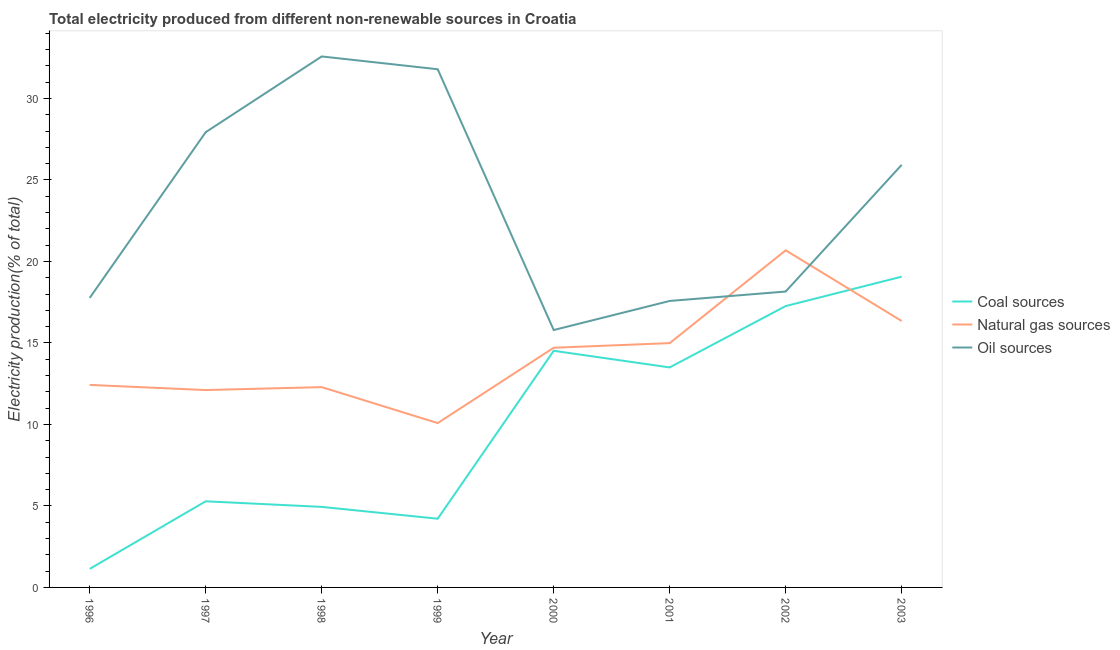Does the line corresponding to percentage of electricity produced by natural gas intersect with the line corresponding to percentage of electricity produced by coal?
Provide a short and direct response. Yes. Is the number of lines equal to the number of legend labels?
Offer a very short reply. Yes. What is the percentage of electricity produced by oil sources in 2002?
Your response must be concise. 18.15. Across all years, what is the maximum percentage of electricity produced by coal?
Provide a succinct answer. 19.06. Across all years, what is the minimum percentage of electricity produced by oil sources?
Provide a succinct answer. 15.79. In which year was the percentage of electricity produced by natural gas minimum?
Your response must be concise. 1999. What is the total percentage of electricity produced by natural gas in the graph?
Ensure brevity in your answer.  113.62. What is the difference between the percentage of electricity produced by oil sources in 1997 and that in 1998?
Your response must be concise. -4.65. What is the difference between the percentage of electricity produced by oil sources in 1997 and the percentage of electricity produced by natural gas in 1999?
Offer a very short reply. 17.85. What is the average percentage of electricity produced by coal per year?
Provide a succinct answer. 9.99. In the year 2002, what is the difference between the percentage of electricity produced by coal and percentage of electricity produced by oil sources?
Offer a terse response. -0.89. What is the ratio of the percentage of electricity produced by coal in 1999 to that in 2001?
Your response must be concise. 0.31. Is the percentage of electricity produced by coal in 1997 less than that in 2003?
Provide a short and direct response. Yes. What is the difference between the highest and the second highest percentage of electricity produced by natural gas?
Give a very brief answer. 4.34. What is the difference between the highest and the lowest percentage of electricity produced by natural gas?
Ensure brevity in your answer.  10.6. Is the sum of the percentage of electricity produced by natural gas in 2000 and 2003 greater than the maximum percentage of electricity produced by oil sources across all years?
Ensure brevity in your answer.  No. Is it the case that in every year, the sum of the percentage of electricity produced by coal and percentage of electricity produced by natural gas is greater than the percentage of electricity produced by oil sources?
Your answer should be compact. No. Is the percentage of electricity produced by natural gas strictly greater than the percentage of electricity produced by oil sources over the years?
Your answer should be very brief. No. Is the percentage of electricity produced by natural gas strictly less than the percentage of electricity produced by oil sources over the years?
Give a very brief answer. No. How many years are there in the graph?
Offer a very short reply. 8. Are the values on the major ticks of Y-axis written in scientific E-notation?
Provide a succinct answer. No. Does the graph contain any zero values?
Keep it short and to the point. No. How are the legend labels stacked?
Give a very brief answer. Vertical. What is the title of the graph?
Your answer should be very brief. Total electricity produced from different non-renewable sources in Croatia. What is the Electricity production(% of total) of Coal sources in 1996?
Your answer should be compact. 1.14. What is the Electricity production(% of total) of Natural gas sources in 1996?
Give a very brief answer. 12.42. What is the Electricity production(% of total) in Oil sources in 1996?
Your answer should be compact. 17.76. What is the Electricity production(% of total) in Coal sources in 1997?
Keep it short and to the point. 5.28. What is the Electricity production(% of total) of Natural gas sources in 1997?
Your answer should be very brief. 12.11. What is the Electricity production(% of total) in Oil sources in 1997?
Provide a short and direct response. 27.93. What is the Electricity production(% of total) in Coal sources in 1998?
Offer a terse response. 4.94. What is the Electricity production(% of total) in Natural gas sources in 1998?
Your response must be concise. 12.29. What is the Electricity production(% of total) in Oil sources in 1998?
Your answer should be very brief. 32.57. What is the Electricity production(% of total) of Coal sources in 1999?
Give a very brief answer. 4.22. What is the Electricity production(% of total) in Natural gas sources in 1999?
Provide a succinct answer. 10.08. What is the Electricity production(% of total) of Oil sources in 1999?
Your response must be concise. 31.79. What is the Electricity production(% of total) of Coal sources in 2000?
Your response must be concise. 14.52. What is the Electricity production(% of total) of Natural gas sources in 2000?
Provide a succinct answer. 14.7. What is the Electricity production(% of total) of Oil sources in 2000?
Give a very brief answer. 15.79. What is the Electricity production(% of total) of Coal sources in 2001?
Make the answer very short. 13.5. What is the Electricity production(% of total) in Natural gas sources in 2001?
Your answer should be very brief. 14.99. What is the Electricity production(% of total) of Oil sources in 2001?
Provide a short and direct response. 17.57. What is the Electricity production(% of total) in Coal sources in 2002?
Provide a short and direct response. 17.26. What is the Electricity production(% of total) in Natural gas sources in 2002?
Offer a very short reply. 20.68. What is the Electricity production(% of total) in Oil sources in 2002?
Offer a terse response. 18.15. What is the Electricity production(% of total) of Coal sources in 2003?
Offer a terse response. 19.06. What is the Electricity production(% of total) of Natural gas sources in 2003?
Provide a succinct answer. 16.34. What is the Electricity production(% of total) of Oil sources in 2003?
Give a very brief answer. 25.92. Across all years, what is the maximum Electricity production(% of total) in Coal sources?
Make the answer very short. 19.06. Across all years, what is the maximum Electricity production(% of total) of Natural gas sources?
Keep it short and to the point. 20.68. Across all years, what is the maximum Electricity production(% of total) of Oil sources?
Your answer should be compact. 32.57. Across all years, what is the minimum Electricity production(% of total) in Coal sources?
Provide a short and direct response. 1.14. Across all years, what is the minimum Electricity production(% of total) of Natural gas sources?
Ensure brevity in your answer.  10.08. Across all years, what is the minimum Electricity production(% of total) in Oil sources?
Offer a terse response. 15.79. What is the total Electricity production(% of total) of Coal sources in the graph?
Offer a terse response. 79.92. What is the total Electricity production(% of total) in Natural gas sources in the graph?
Your answer should be compact. 113.62. What is the total Electricity production(% of total) in Oil sources in the graph?
Keep it short and to the point. 187.5. What is the difference between the Electricity production(% of total) in Coal sources in 1996 and that in 1997?
Offer a very short reply. -4.15. What is the difference between the Electricity production(% of total) in Natural gas sources in 1996 and that in 1997?
Give a very brief answer. 0.31. What is the difference between the Electricity production(% of total) of Oil sources in 1996 and that in 1997?
Keep it short and to the point. -10.16. What is the difference between the Electricity production(% of total) in Coal sources in 1996 and that in 1998?
Ensure brevity in your answer.  -3.8. What is the difference between the Electricity production(% of total) in Natural gas sources in 1996 and that in 1998?
Offer a terse response. 0.13. What is the difference between the Electricity production(% of total) of Oil sources in 1996 and that in 1998?
Provide a short and direct response. -14.81. What is the difference between the Electricity production(% of total) of Coal sources in 1996 and that in 1999?
Your response must be concise. -3.08. What is the difference between the Electricity production(% of total) in Natural gas sources in 1996 and that in 1999?
Your answer should be very brief. 2.34. What is the difference between the Electricity production(% of total) in Oil sources in 1996 and that in 1999?
Offer a terse response. -14.02. What is the difference between the Electricity production(% of total) of Coal sources in 1996 and that in 2000?
Your response must be concise. -13.38. What is the difference between the Electricity production(% of total) of Natural gas sources in 1996 and that in 2000?
Provide a succinct answer. -2.28. What is the difference between the Electricity production(% of total) of Oil sources in 1996 and that in 2000?
Provide a short and direct response. 1.97. What is the difference between the Electricity production(% of total) of Coal sources in 1996 and that in 2001?
Make the answer very short. -12.36. What is the difference between the Electricity production(% of total) of Natural gas sources in 1996 and that in 2001?
Provide a succinct answer. -2.57. What is the difference between the Electricity production(% of total) in Oil sources in 1996 and that in 2001?
Provide a short and direct response. 0.19. What is the difference between the Electricity production(% of total) in Coal sources in 1996 and that in 2002?
Your answer should be compact. -16.12. What is the difference between the Electricity production(% of total) in Natural gas sources in 1996 and that in 2002?
Provide a succinct answer. -8.26. What is the difference between the Electricity production(% of total) in Oil sources in 1996 and that in 2002?
Your answer should be very brief. -0.39. What is the difference between the Electricity production(% of total) of Coal sources in 1996 and that in 2003?
Ensure brevity in your answer.  -17.93. What is the difference between the Electricity production(% of total) in Natural gas sources in 1996 and that in 2003?
Keep it short and to the point. -3.92. What is the difference between the Electricity production(% of total) of Oil sources in 1996 and that in 2003?
Provide a short and direct response. -8.16. What is the difference between the Electricity production(% of total) in Coal sources in 1997 and that in 1998?
Your response must be concise. 0.34. What is the difference between the Electricity production(% of total) of Natural gas sources in 1997 and that in 1998?
Give a very brief answer. -0.18. What is the difference between the Electricity production(% of total) in Oil sources in 1997 and that in 1998?
Provide a succinct answer. -4.65. What is the difference between the Electricity production(% of total) of Coal sources in 1997 and that in 1999?
Keep it short and to the point. 1.07. What is the difference between the Electricity production(% of total) of Natural gas sources in 1997 and that in 1999?
Give a very brief answer. 2.03. What is the difference between the Electricity production(% of total) of Oil sources in 1997 and that in 1999?
Your answer should be compact. -3.86. What is the difference between the Electricity production(% of total) of Coal sources in 1997 and that in 2000?
Offer a very short reply. -9.23. What is the difference between the Electricity production(% of total) in Natural gas sources in 1997 and that in 2000?
Your response must be concise. -2.6. What is the difference between the Electricity production(% of total) of Oil sources in 1997 and that in 2000?
Provide a succinct answer. 12.14. What is the difference between the Electricity production(% of total) of Coal sources in 1997 and that in 2001?
Keep it short and to the point. -8.21. What is the difference between the Electricity production(% of total) of Natural gas sources in 1997 and that in 2001?
Your answer should be compact. -2.88. What is the difference between the Electricity production(% of total) of Oil sources in 1997 and that in 2001?
Offer a terse response. 10.35. What is the difference between the Electricity production(% of total) of Coal sources in 1997 and that in 2002?
Give a very brief answer. -11.98. What is the difference between the Electricity production(% of total) in Natural gas sources in 1997 and that in 2002?
Your answer should be very brief. -8.57. What is the difference between the Electricity production(% of total) in Oil sources in 1997 and that in 2002?
Offer a very short reply. 9.78. What is the difference between the Electricity production(% of total) in Coal sources in 1997 and that in 2003?
Your answer should be compact. -13.78. What is the difference between the Electricity production(% of total) of Natural gas sources in 1997 and that in 2003?
Ensure brevity in your answer.  -4.24. What is the difference between the Electricity production(% of total) of Oil sources in 1997 and that in 2003?
Keep it short and to the point. 2. What is the difference between the Electricity production(% of total) in Coal sources in 1998 and that in 1999?
Give a very brief answer. 0.73. What is the difference between the Electricity production(% of total) of Natural gas sources in 1998 and that in 1999?
Make the answer very short. 2.21. What is the difference between the Electricity production(% of total) of Oil sources in 1998 and that in 1999?
Ensure brevity in your answer.  0.78. What is the difference between the Electricity production(% of total) of Coal sources in 1998 and that in 2000?
Your answer should be very brief. -9.58. What is the difference between the Electricity production(% of total) of Natural gas sources in 1998 and that in 2000?
Give a very brief answer. -2.42. What is the difference between the Electricity production(% of total) in Oil sources in 1998 and that in 2000?
Provide a succinct answer. 16.78. What is the difference between the Electricity production(% of total) in Coal sources in 1998 and that in 2001?
Your response must be concise. -8.56. What is the difference between the Electricity production(% of total) of Natural gas sources in 1998 and that in 2001?
Ensure brevity in your answer.  -2.7. What is the difference between the Electricity production(% of total) in Oil sources in 1998 and that in 2001?
Make the answer very short. 15. What is the difference between the Electricity production(% of total) of Coal sources in 1998 and that in 2002?
Keep it short and to the point. -12.32. What is the difference between the Electricity production(% of total) of Natural gas sources in 1998 and that in 2002?
Ensure brevity in your answer.  -8.39. What is the difference between the Electricity production(% of total) in Oil sources in 1998 and that in 2002?
Keep it short and to the point. 14.42. What is the difference between the Electricity production(% of total) of Coal sources in 1998 and that in 2003?
Your answer should be compact. -14.12. What is the difference between the Electricity production(% of total) in Natural gas sources in 1998 and that in 2003?
Provide a short and direct response. -4.06. What is the difference between the Electricity production(% of total) of Oil sources in 1998 and that in 2003?
Give a very brief answer. 6.65. What is the difference between the Electricity production(% of total) of Coal sources in 1999 and that in 2000?
Your answer should be very brief. -10.3. What is the difference between the Electricity production(% of total) of Natural gas sources in 1999 and that in 2000?
Provide a short and direct response. -4.62. What is the difference between the Electricity production(% of total) in Oil sources in 1999 and that in 2000?
Give a very brief answer. 16. What is the difference between the Electricity production(% of total) of Coal sources in 1999 and that in 2001?
Your response must be concise. -9.28. What is the difference between the Electricity production(% of total) in Natural gas sources in 1999 and that in 2001?
Offer a very short reply. -4.91. What is the difference between the Electricity production(% of total) in Oil sources in 1999 and that in 2001?
Give a very brief answer. 14.21. What is the difference between the Electricity production(% of total) of Coal sources in 1999 and that in 2002?
Make the answer very short. -13.04. What is the difference between the Electricity production(% of total) of Natural gas sources in 1999 and that in 2002?
Make the answer very short. -10.6. What is the difference between the Electricity production(% of total) of Oil sources in 1999 and that in 2002?
Your answer should be very brief. 13.64. What is the difference between the Electricity production(% of total) of Coal sources in 1999 and that in 2003?
Ensure brevity in your answer.  -14.85. What is the difference between the Electricity production(% of total) of Natural gas sources in 1999 and that in 2003?
Offer a terse response. -6.26. What is the difference between the Electricity production(% of total) in Oil sources in 1999 and that in 2003?
Your answer should be very brief. 5.87. What is the difference between the Electricity production(% of total) of Coal sources in 2000 and that in 2001?
Keep it short and to the point. 1.02. What is the difference between the Electricity production(% of total) in Natural gas sources in 2000 and that in 2001?
Provide a succinct answer. -0.28. What is the difference between the Electricity production(% of total) in Oil sources in 2000 and that in 2001?
Ensure brevity in your answer.  -1.78. What is the difference between the Electricity production(% of total) of Coal sources in 2000 and that in 2002?
Make the answer very short. -2.74. What is the difference between the Electricity production(% of total) in Natural gas sources in 2000 and that in 2002?
Your answer should be very brief. -5.98. What is the difference between the Electricity production(% of total) of Oil sources in 2000 and that in 2002?
Provide a succinct answer. -2.36. What is the difference between the Electricity production(% of total) of Coal sources in 2000 and that in 2003?
Provide a short and direct response. -4.55. What is the difference between the Electricity production(% of total) of Natural gas sources in 2000 and that in 2003?
Offer a very short reply. -1.64. What is the difference between the Electricity production(% of total) in Oil sources in 2000 and that in 2003?
Keep it short and to the point. -10.13. What is the difference between the Electricity production(% of total) of Coal sources in 2001 and that in 2002?
Make the answer very short. -3.76. What is the difference between the Electricity production(% of total) of Natural gas sources in 2001 and that in 2002?
Make the answer very short. -5.69. What is the difference between the Electricity production(% of total) of Oil sources in 2001 and that in 2002?
Give a very brief answer. -0.58. What is the difference between the Electricity production(% of total) in Coal sources in 2001 and that in 2003?
Give a very brief answer. -5.57. What is the difference between the Electricity production(% of total) of Natural gas sources in 2001 and that in 2003?
Your response must be concise. -1.36. What is the difference between the Electricity production(% of total) in Oil sources in 2001 and that in 2003?
Your answer should be compact. -8.35. What is the difference between the Electricity production(% of total) in Coal sources in 2002 and that in 2003?
Offer a very short reply. -1.8. What is the difference between the Electricity production(% of total) in Natural gas sources in 2002 and that in 2003?
Offer a very short reply. 4.34. What is the difference between the Electricity production(% of total) of Oil sources in 2002 and that in 2003?
Give a very brief answer. -7.77. What is the difference between the Electricity production(% of total) of Coal sources in 1996 and the Electricity production(% of total) of Natural gas sources in 1997?
Your answer should be compact. -10.97. What is the difference between the Electricity production(% of total) of Coal sources in 1996 and the Electricity production(% of total) of Oil sources in 1997?
Ensure brevity in your answer.  -26.79. What is the difference between the Electricity production(% of total) of Natural gas sources in 1996 and the Electricity production(% of total) of Oil sources in 1997?
Provide a short and direct response. -15.51. What is the difference between the Electricity production(% of total) of Coal sources in 1996 and the Electricity production(% of total) of Natural gas sources in 1998?
Your answer should be very brief. -11.15. What is the difference between the Electricity production(% of total) of Coal sources in 1996 and the Electricity production(% of total) of Oil sources in 1998?
Your answer should be compact. -31.44. What is the difference between the Electricity production(% of total) in Natural gas sources in 1996 and the Electricity production(% of total) in Oil sources in 1998?
Make the answer very short. -20.15. What is the difference between the Electricity production(% of total) in Coal sources in 1996 and the Electricity production(% of total) in Natural gas sources in 1999?
Give a very brief answer. -8.94. What is the difference between the Electricity production(% of total) in Coal sources in 1996 and the Electricity production(% of total) in Oil sources in 1999?
Provide a short and direct response. -30.65. What is the difference between the Electricity production(% of total) in Natural gas sources in 1996 and the Electricity production(% of total) in Oil sources in 1999?
Ensure brevity in your answer.  -19.37. What is the difference between the Electricity production(% of total) in Coal sources in 1996 and the Electricity production(% of total) in Natural gas sources in 2000?
Ensure brevity in your answer.  -13.57. What is the difference between the Electricity production(% of total) of Coal sources in 1996 and the Electricity production(% of total) of Oil sources in 2000?
Ensure brevity in your answer.  -14.65. What is the difference between the Electricity production(% of total) of Natural gas sources in 1996 and the Electricity production(% of total) of Oil sources in 2000?
Your response must be concise. -3.37. What is the difference between the Electricity production(% of total) of Coal sources in 1996 and the Electricity production(% of total) of Natural gas sources in 2001?
Make the answer very short. -13.85. What is the difference between the Electricity production(% of total) in Coal sources in 1996 and the Electricity production(% of total) in Oil sources in 2001?
Provide a succinct answer. -16.44. What is the difference between the Electricity production(% of total) in Natural gas sources in 1996 and the Electricity production(% of total) in Oil sources in 2001?
Ensure brevity in your answer.  -5.15. What is the difference between the Electricity production(% of total) in Coal sources in 1996 and the Electricity production(% of total) in Natural gas sources in 2002?
Offer a terse response. -19.54. What is the difference between the Electricity production(% of total) of Coal sources in 1996 and the Electricity production(% of total) of Oil sources in 2002?
Ensure brevity in your answer.  -17.01. What is the difference between the Electricity production(% of total) in Natural gas sources in 1996 and the Electricity production(% of total) in Oil sources in 2002?
Provide a succinct answer. -5.73. What is the difference between the Electricity production(% of total) in Coal sources in 1996 and the Electricity production(% of total) in Natural gas sources in 2003?
Your answer should be very brief. -15.21. What is the difference between the Electricity production(% of total) of Coal sources in 1996 and the Electricity production(% of total) of Oil sources in 2003?
Your answer should be very brief. -24.79. What is the difference between the Electricity production(% of total) in Natural gas sources in 1996 and the Electricity production(% of total) in Oil sources in 2003?
Make the answer very short. -13.5. What is the difference between the Electricity production(% of total) of Coal sources in 1997 and the Electricity production(% of total) of Natural gas sources in 1998?
Give a very brief answer. -7. What is the difference between the Electricity production(% of total) of Coal sources in 1997 and the Electricity production(% of total) of Oil sources in 1998?
Your answer should be compact. -27.29. What is the difference between the Electricity production(% of total) of Natural gas sources in 1997 and the Electricity production(% of total) of Oil sources in 1998?
Provide a short and direct response. -20.47. What is the difference between the Electricity production(% of total) in Coal sources in 1997 and the Electricity production(% of total) in Natural gas sources in 1999?
Your response must be concise. -4.8. What is the difference between the Electricity production(% of total) in Coal sources in 1997 and the Electricity production(% of total) in Oil sources in 1999?
Your answer should be very brief. -26.51. What is the difference between the Electricity production(% of total) of Natural gas sources in 1997 and the Electricity production(% of total) of Oil sources in 1999?
Provide a succinct answer. -19.68. What is the difference between the Electricity production(% of total) in Coal sources in 1997 and the Electricity production(% of total) in Natural gas sources in 2000?
Make the answer very short. -9.42. What is the difference between the Electricity production(% of total) in Coal sources in 1997 and the Electricity production(% of total) in Oil sources in 2000?
Provide a succinct answer. -10.51. What is the difference between the Electricity production(% of total) of Natural gas sources in 1997 and the Electricity production(% of total) of Oil sources in 2000?
Offer a very short reply. -3.68. What is the difference between the Electricity production(% of total) in Coal sources in 1997 and the Electricity production(% of total) in Natural gas sources in 2001?
Offer a very short reply. -9.7. What is the difference between the Electricity production(% of total) in Coal sources in 1997 and the Electricity production(% of total) in Oil sources in 2001?
Your answer should be compact. -12.29. What is the difference between the Electricity production(% of total) in Natural gas sources in 1997 and the Electricity production(% of total) in Oil sources in 2001?
Ensure brevity in your answer.  -5.47. What is the difference between the Electricity production(% of total) of Coal sources in 1997 and the Electricity production(% of total) of Natural gas sources in 2002?
Provide a short and direct response. -15.4. What is the difference between the Electricity production(% of total) of Coal sources in 1997 and the Electricity production(% of total) of Oil sources in 2002?
Your answer should be very brief. -12.87. What is the difference between the Electricity production(% of total) in Natural gas sources in 1997 and the Electricity production(% of total) in Oil sources in 2002?
Ensure brevity in your answer.  -6.04. What is the difference between the Electricity production(% of total) in Coal sources in 1997 and the Electricity production(% of total) in Natural gas sources in 2003?
Provide a succinct answer. -11.06. What is the difference between the Electricity production(% of total) of Coal sources in 1997 and the Electricity production(% of total) of Oil sources in 2003?
Make the answer very short. -20.64. What is the difference between the Electricity production(% of total) of Natural gas sources in 1997 and the Electricity production(% of total) of Oil sources in 2003?
Provide a short and direct response. -13.82. What is the difference between the Electricity production(% of total) in Coal sources in 1998 and the Electricity production(% of total) in Natural gas sources in 1999?
Give a very brief answer. -5.14. What is the difference between the Electricity production(% of total) in Coal sources in 1998 and the Electricity production(% of total) in Oil sources in 1999?
Make the answer very short. -26.85. What is the difference between the Electricity production(% of total) of Natural gas sources in 1998 and the Electricity production(% of total) of Oil sources in 1999?
Your answer should be compact. -19.5. What is the difference between the Electricity production(% of total) of Coal sources in 1998 and the Electricity production(% of total) of Natural gas sources in 2000?
Ensure brevity in your answer.  -9.76. What is the difference between the Electricity production(% of total) of Coal sources in 1998 and the Electricity production(% of total) of Oil sources in 2000?
Your answer should be compact. -10.85. What is the difference between the Electricity production(% of total) of Natural gas sources in 1998 and the Electricity production(% of total) of Oil sources in 2000?
Make the answer very short. -3.5. What is the difference between the Electricity production(% of total) of Coal sources in 1998 and the Electricity production(% of total) of Natural gas sources in 2001?
Ensure brevity in your answer.  -10.05. What is the difference between the Electricity production(% of total) in Coal sources in 1998 and the Electricity production(% of total) in Oil sources in 2001?
Give a very brief answer. -12.63. What is the difference between the Electricity production(% of total) in Natural gas sources in 1998 and the Electricity production(% of total) in Oil sources in 2001?
Provide a short and direct response. -5.29. What is the difference between the Electricity production(% of total) of Coal sources in 1998 and the Electricity production(% of total) of Natural gas sources in 2002?
Your response must be concise. -15.74. What is the difference between the Electricity production(% of total) of Coal sources in 1998 and the Electricity production(% of total) of Oil sources in 2002?
Keep it short and to the point. -13.21. What is the difference between the Electricity production(% of total) of Natural gas sources in 1998 and the Electricity production(% of total) of Oil sources in 2002?
Ensure brevity in your answer.  -5.86. What is the difference between the Electricity production(% of total) of Coal sources in 1998 and the Electricity production(% of total) of Natural gas sources in 2003?
Your answer should be compact. -11.4. What is the difference between the Electricity production(% of total) of Coal sources in 1998 and the Electricity production(% of total) of Oil sources in 2003?
Your answer should be compact. -20.98. What is the difference between the Electricity production(% of total) of Natural gas sources in 1998 and the Electricity production(% of total) of Oil sources in 2003?
Offer a very short reply. -13.64. What is the difference between the Electricity production(% of total) of Coal sources in 1999 and the Electricity production(% of total) of Natural gas sources in 2000?
Your response must be concise. -10.49. What is the difference between the Electricity production(% of total) of Coal sources in 1999 and the Electricity production(% of total) of Oil sources in 2000?
Offer a very short reply. -11.57. What is the difference between the Electricity production(% of total) in Natural gas sources in 1999 and the Electricity production(% of total) in Oil sources in 2000?
Keep it short and to the point. -5.71. What is the difference between the Electricity production(% of total) in Coal sources in 1999 and the Electricity production(% of total) in Natural gas sources in 2001?
Ensure brevity in your answer.  -10.77. What is the difference between the Electricity production(% of total) in Coal sources in 1999 and the Electricity production(% of total) in Oil sources in 2001?
Ensure brevity in your answer.  -13.36. What is the difference between the Electricity production(% of total) of Natural gas sources in 1999 and the Electricity production(% of total) of Oil sources in 2001?
Keep it short and to the point. -7.49. What is the difference between the Electricity production(% of total) in Coal sources in 1999 and the Electricity production(% of total) in Natural gas sources in 2002?
Your answer should be compact. -16.47. What is the difference between the Electricity production(% of total) in Coal sources in 1999 and the Electricity production(% of total) in Oil sources in 2002?
Your response must be concise. -13.94. What is the difference between the Electricity production(% of total) in Natural gas sources in 1999 and the Electricity production(% of total) in Oil sources in 2002?
Provide a succinct answer. -8.07. What is the difference between the Electricity production(% of total) of Coal sources in 1999 and the Electricity production(% of total) of Natural gas sources in 2003?
Ensure brevity in your answer.  -12.13. What is the difference between the Electricity production(% of total) in Coal sources in 1999 and the Electricity production(% of total) in Oil sources in 2003?
Keep it short and to the point. -21.71. What is the difference between the Electricity production(% of total) of Natural gas sources in 1999 and the Electricity production(% of total) of Oil sources in 2003?
Offer a very short reply. -15.84. What is the difference between the Electricity production(% of total) in Coal sources in 2000 and the Electricity production(% of total) in Natural gas sources in 2001?
Offer a very short reply. -0.47. What is the difference between the Electricity production(% of total) of Coal sources in 2000 and the Electricity production(% of total) of Oil sources in 2001?
Provide a succinct answer. -3.06. What is the difference between the Electricity production(% of total) in Natural gas sources in 2000 and the Electricity production(% of total) in Oil sources in 2001?
Your response must be concise. -2.87. What is the difference between the Electricity production(% of total) of Coal sources in 2000 and the Electricity production(% of total) of Natural gas sources in 2002?
Your answer should be compact. -6.16. What is the difference between the Electricity production(% of total) of Coal sources in 2000 and the Electricity production(% of total) of Oil sources in 2002?
Make the answer very short. -3.63. What is the difference between the Electricity production(% of total) in Natural gas sources in 2000 and the Electricity production(% of total) in Oil sources in 2002?
Ensure brevity in your answer.  -3.45. What is the difference between the Electricity production(% of total) of Coal sources in 2000 and the Electricity production(% of total) of Natural gas sources in 2003?
Make the answer very short. -1.83. What is the difference between the Electricity production(% of total) of Coal sources in 2000 and the Electricity production(% of total) of Oil sources in 2003?
Your response must be concise. -11.41. What is the difference between the Electricity production(% of total) in Natural gas sources in 2000 and the Electricity production(% of total) in Oil sources in 2003?
Make the answer very short. -11.22. What is the difference between the Electricity production(% of total) in Coal sources in 2001 and the Electricity production(% of total) in Natural gas sources in 2002?
Your response must be concise. -7.18. What is the difference between the Electricity production(% of total) in Coal sources in 2001 and the Electricity production(% of total) in Oil sources in 2002?
Offer a very short reply. -4.66. What is the difference between the Electricity production(% of total) of Natural gas sources in 2001 and the Electricity production(% of total) of Oil sources in 2002?
Your answer should be compact. -3.16. What is the difference between the Electricity production(% of total) in Coal sources in 2001 and the Electricity production(% of total) in Natural gas sources in 2003?
Your answer should be compact. -2.85. What is the difference between the Electricity production(% of total) in Coal sources in 2001 and the Electricity production(% of total) in Oil sources in 2003?
Keep it short and to the point. -12.43. What is the difference between the Electricity production(% of total) in Natural gas sources in 2001 and the Electricity production(% of total) in Oil sources in 2003?
Give a very brief answer. -10.94. What is the difference between the Electricity production(% of total) of Coal sources in 2002 and the Electricity production(% of total) of Natural gas sources in 2003?
Offer a very short reply. 0.92. What is the difference between the Electricity production(% of total) in Coal sources in 2002 and the Electricity production(% of total) in Oil sources in 2003?
Ensure brevity in your answer.  -8.66. What is the difference between the Electricity production(% of total) of Natural gas sources in 2002 and the Electricity production(% of total) of Oil sources in 2003?
Give a very brief answer. -5.24. What is the average Electricity production(% of total) in Coal sources per year?
Your response must be concise. 9.99. What is the average Electricity production(% of total) in Natural gas sources per year?
Ensure brevity in your answer.  14.2. What is the average Electricity production(% of total) of Oil sources per year?
Keep it short and to the point. 23.44. In the year 1996, what is the difference between the Electricity production(% of total) of Coal sources and Electricity production(% of total) of Natural gas sources?
Provide a succinct answer. -11.28. In the year 1996, what is the difference between the Electricity production(% of total) of Coal sources and Electricity production(% of total) of Oil sources?
Provide a short and direct response. -16.63. In the year 1996, what is the difference between the Electricity production(% of total) in Natural gas sources and Electricity production(% of total) in Oil sources?
Make the answer very short. -5.34. In the year 1997, what is the difference between the Electricity production(% of total) in Coal sources and Electricity production(% of total) in Natural gas sources?
Provide a short and direct response. -6.82. In the year 1997, what is the difference between the Electricity production(% of total) of Coal sources and Electricity production(% of total) of Oil sources?
Ensure brevity in your answer.  -22.64. In the year 1997, what is the difference between the Electricity production(% of total) of Natural gas sources and Electricity production(% of total) of Oil sources?
Make the answer very short. -15.82. In the year 1998, what is the difference between the Electricity production(% of total) in Coal sources and Electricity production(% of total) in Natural gas sources?
Give a very brief answer. -7.35. In the year 1998, what is the difference between the Electricity production(% of total) in Coal sources and Electricity production(% of total) in Oil sources?
Make the answer very short. -27.63. In the year 1998, what is the difference between the Electricity production(% of total) of Natural gas sources and Electricity production(% of total) of Oil sources?
Provide a succinct answer. -20.29. In the year 1999, what is the difference between the Electricity production(% of total) of Coal sources and Electricity production(% of total) of Natural gas sources?
Provide a short and direct response. -5.87. In the year 1999, what is the difference between the Electricity production(% of total) of Coal sources and Electricity production(% of total) of Oil sources?
Your answer should be very brief. -27.57. In the year 1999, what is the difference between the Electricity production(% of total) of Natural gas sources and Electricity production(% of total) of Oil sources?
Provide a short and direct response. -21.71. In the year 2000, what is the difference between the Electricity production(% of total) of Coal sources and Electricity production(% of total) of Natural gas sources?
Provide a short and direct response. -0.19. In the year 2000, what is the difference between the Electricity production(% of total) of Coal sources and Electricity production(% of total) of Oil sources?
Keep it short and to the point. -1.27. In the year 2000, what is the difference between the Electricity production(% of total) of Natural gas sources and Electricity production(% of total) of Oil sources?
Keep it short and to the point. -1.09. In the year 2001, what is the difference between the Electricity production(% of total) in Coal sources and Electricity production(% of total) in Natural gas sources?
Give a very brief answer. -1.49. In the year 2001, what is the difference between the Electricity production(% of total) in Coal sources and Electricity production(% of total) in Oil sources?
Give a very brief answer. -4.08. In the year 2001, what is the difference between the Electricity production(% of total) of Natural gas sources and Electricity production(% of total) of Oil sources?
Your response must be concise. -2.59. In the year 2002, what is the difference between the Electricity production(% of total) of Coal sources and Electricity production(% of total) of Natural gas sources?
Give a very brief answer. -3.42. In the year 2002, what is the difference between the Electricity production(% of total) of Coal sources and Electricity production(% of total) of Oil sources?
Make the answer very short. -0.89. In the year 2002, what is the difference between the Electricity production(% of total) of Natural gas sources and Electricity production(% of total) of Oil sources?
Offer a terse response. 2.53. In the year 2003, what is the difference between the Electricity production(% of total) in Coal sources and Electricity production(% of total) in Natural gas sources?
Give a very brief answer. 2.72. In the year 2003, what is the difference between the Electricity production(% of total) of Coal sources and Electricity production(% of total) of Oil sources?
Provide a succinct answer. -6.86. In the year 2003, what is the difference between the Electricity production(% of total) of Natural gas sources and Electricity production(% of total) of Oil sources?
Provide a succinct answer. -9.58. What is the ratio of the Electricity production(% of total) in Coal sources in 1996 to that in 1997?
Keep it short and to the point. 0.22. What is the ratio of the Electricity production(% of total) in Natural gas sources in 1996 to that in 1997?
Keep it short and to the point. 1.03. What is the ratio of the Electricity production(% of total) of Oil sources in 1996 to that in 1997?
Your answer should be very brief. 0.64. What is the ratio of the Electricity production(% of total) in Coal sources in 1996 to that in 1998?
Give a very brief answer. 0.23. What is the ratio of the Electricity production(% of total) of Natural gas sources in 1996 to that in 1998?
Your answer should be very brief. 1.01. What is the ratio of the Electricity production(% of total) of Oil sources in 1996 to that in 1998?
Offer a very short reply. 0.55. What is the ratio of the Electricity production(% of total) of Coal sources in 1996 to that in 1999?
Keep it short and to the point. 0.27. What is the ratio of the Electricity production(% of total) of Natural gas sources in 1996 to that in 1999?
Your answer should be compact. 1.23. What is the ratio of the Electricity production(% of total) of Oil sources in 1996 to that in 1999?
Keep it short and to the point. 0.56. What is the ratio of the Electricity production(% of total) of Coal sources in 1996 to that in 2000?
Your answer should be very brief. 0.08. What is the ratio of the Electricity production(% of total) in Natural gas sources in 1996 to that in 2000?
Offer a terse response. 0.84. What is the ratio of the Electricity production(% of total) of Oil sources in 1996 to that in 2000?
Offer a very short reply. 1.12. What is the ratio of the Electricity production(% of total) of Coal sources in 1996 to that in 2001?
Your answer should be compact. 0.08. What is the ratio of the Electricity production(% of total) in Natural gas sources in 1996 to that in 2001?
Provide a succinct answer. 0.83. What is the ratio of the Electricity production(% of total) in Oil sources in 1996 to that in 2001?
Ensure brevity in your answer.  1.01. What is the ratio of the Electricity production(% of total) in Coal sources in 1996 to that in 2002?
Provide a succinct answer. 0.07. What is the ratio of the Electricity production(% of total) in Natural gas sources in 1996 to that in 2002?
Give a very brief answer. 0.6. What is the ratio of the Electricity production(% of total) of Oil sources in 1996 to that in 2002?
Provide a short and direct response. 0.98. What is the ratio of the Electricity production(% of total) in Coal sources in 1996 to that in 2003?
Your answer should be very brief. 0.06. What is the ratio of the Electricity production(% of total) in Natural gas sources in 1996 to that in 2003?
Provide a short and direct response. 0.76. What is the ratio of the Electricity production(% of total) in Oil sources in 1996 to that in 2003?
Provide a succinct answer. 0.69. What is the ratio of the Electricity production(% of total) of Coal sources in 1997 to that in 1998?
Offer a very short reply. 1.07. What is the ratio of the Electricity production(% of total) of Natural gas sources in 1997 to that in 1998?
Your response must be concise. 0.99. What is the ratio of the Electricity production(% of total) of Oil sources in 1997 to that in 1998?
Provide a succinct answer. 0.86. What is the ratio of the Electricity production(% of total) of Coal sources in 1997 to that in 1999?
Ensure brevity in your answer.  1.25. What is the ratio of the Electricity production(% of total) of Natural gas sources in 1997 to that in 1999?
Offer a terse response. 1.2. What is the ratio of the Electricity production(% of total) in Oil sources in 1997 to that in 1999?
Give a very brief answer. 0.88. What is the ratio of the Electricity production(% of total) in Coal sources in 1997 to that in 2000?
Your answer should be compact. 0.36. What is the ratio of the Electricity production(% of total) of Natural gas sources in 1997 to that in 2000?
Provide a succinct answer. 0.82. What is the ratio of the Electricity production(% of total) of Oil sources in 1997 to that in 2000?
Provide a succinct answer. 1.77. What is the ratio of the Electricity production(% of total) in Coal sources in 1997 to that in 2001?
Your response must be concise. 0.39. What is the ratio of the Electricity production(% of total) in Natural gas sources in 1997 to that in 2001?
Give a very brief answer. 0.81. What is the ratio of the Electricity production(% of total) of Oil sources in 1997 to that in 2001?
Keep it short and to the point. 1.59. What is the ratio of the Electricity production(% of total) of Coal sources in 1997 to that in 2002?
Your answer should be compact. 0.31. What is the ratio of the Electricity production(% of total) in Natural gas sources in 1997 to that in 2002?
Give a very brief answer. 0.59. What is the ratio of the Electricity production(% of total) in Oil sources in 1997 to that in 2002?
Your response must be concise. 1.54. What is the ratio of the Electricity production(% of total) of Coal sources in 1997 to that in 2003?
Your answer should be compact. 0.28. What is the ratio of the Electricity production(% of total) in Natural gas sources in 1997 to that in 2003?
Offer a terse response. 0.74. What is the ratio of the Electricity production(% of total) of Oil sources in 1997 to that in 2003?
Your response must be concise. 1.08. What is the ratio of the Electricity production(% of total) of Coal sources in 1998 to that in 1999?
Give a very brief answer. 1.17. What is the ratio of the Electricity production(% of total) of Natural gas sources in 1998 to that in 1999?
Keep it short and to the point. 1.22. What is the ratio of the Electricity production(% of total) in Oil sources in 1998 to that in 1999?
Make the answer very short. 1.02. What is the ratio of the Electricity production(% of total) in Coal sources in 1998 to that in 2000?
Your answer should be compact. 0.34. What is the ratio of the Electricity production(% of total) of Natural gas sources in 1998 to that in 2000?
Your answer should be very brief. 0.84. What is the ratio of the Electricity production(% of total) of Oil sources in 1998 to that in 2000?
Provide a short and direct response. 2.06. What is the ratio of the Electricity production(% of total) of Coal sources in 1998 to that in 2001?
Offer a very short reply. 0.37. What is the ratio of the Electricity production(% of total) in Natural gas sources in 1998 to that in 2001?
Your response must be concise. 0.82. What is the ratio of the Electricity production(% of total) of Oil sources in 1998 to that in 2001?
Your answer should be very brief. 1.85. What is the ratio of the Electricity production(% of total) of Coal sources in 1998 to that in 2002?
Give a very brief answer. 0.29. What is the ratio of the Electricity production(% of total) in Natural gas sources in 1998 to that in 2002?
Make the answer very short. 0.59. What is the ratio of the Electricity production(% of total) of Oil sources in 1998 to that in 2002?
Offer a very short reply. 1.79. What is the ratio of the Electricity production(% of total) of Coal sources in 1998 to that in 2003?
Your answer should be compact. 0.26. What is the ratio of the Electricity production(% of total) in Natural gas sources in 1998 to that in 2003?
Your response must be concise. 0.75. What is the ratio of the Electricity production(% of total) in Oil sources in 1998 to that in 2003?
Offer a very short reply. 1.26. What is the ratio of the Electricity production(% of total) in Coal sources in 1999 to that in 2000?
Make the answer very short. 0.29. What is the ratio of the Electricity production(% of total) in Natural gas sources in 1999 to that in 2000?
Make the answer very short. 0.69. What is the ratio of the Electricity production(% of total) in Oil sources in 1999 to that in 2000?
Provide a short and direct response. 2.01. What is the ratio of the Electricity production(% of total) of Coal sources in 1999 to that in 2001?
Keep it short and to the point. 0.31. What is the ratio of the Electricity production(% of total) of Natural gas sources in 1999 to that in 2001?
Keep it short and to the point. 0.67. What is the ratio of the Electricity production(% of total) of Oil sources in 1999 to that in 2001?
Provide a short and direct response. 1.81. What is the ratio of the Electricity production(% of total) of Coal sources in 1999 to that in 2002?
Keep it short and to the point. 0.24. What is the ratio of the Electricity production(% of total) of Natural gas sources in 1999 to that in 2002?
Your answer should be compact. 0.49. What is the ratio of the Electricity production(% of total) of Oil sources in 1999 to that in 2002?
Your answer should be very brief. 1.75. What is the ratio of the Electricity production(% of total) in Coal sources in 1999 to that in 2003?
Keep it short and to the point. 0.22. What is the ratio of the Electricity production(% of total) in Natural gas sources in 1999 to that in 2003?
Provide a succinct answer. 0.62. What is the ratio of the Electricity production(% of total) in Oil sources in 1999 to that in 2003?
Your answer should be very brief. 1.23. What is the ratio of the Electricity production(% of total) in Coal sources in 2000 to that in 2001?
Your answer should be compact. 1.08. What is the ratio of the Electricity production(% of total) in Natural gas sources in 2000 to that in 2001?
Your response must be concise. 0.98. What is the ratio of the Electricity production(% of total) in Oil sources in 2000 to that in 2001?
Your response must be concise. 0.9. What is the ratio of the Electricity production(% of total) in Coal sources in 2000 to that in 2002?
Make the answer very short. 0.84. What is the ratio of the Electricity production(% of total) in Natural gas sources in 2000 to that in 2002?
Make the answer very short. 0.71. What is the ratio of the Electricity production(% of total) in Oil sources in 2000 to that in 2002?
Keep it short and to the point. 0.87. What is the ratio of the Electricity production(% of total) in Coal sources in 2000 to that in 2003?
Make the answer very short. 0.76. What is the ratio of the Electricity production(% of total) of Natural gas sources in 2000 to that in 2003?
Your answer should be very brief. 0.9. What is the ratio of the Electricity production(% of total) of Oil sources in 2000 to that in 2003?
Your response must be concise. 0.61. What is the ratio of the Electricity production(% of total) in Coal sources in 2001 to that in 2002?
Give a very brief answer. 0.78. What is the ratio of the Electricity production(% of total) in Natural gas sources in 2001 to that in 2002?
Your answer should be very brief. 0.72. What is the ratio of the Electricity production(% of total) of Oil sources in 2001 to that in 2002?
Ensure brevity in your answer.  0.97. What is the ratio of the Electricity production(% of total) of Coal sources in 2001 to that in 2003?
Offer a very short reply. 0.71. What is the ratio of the Electricity production(% of total) of Natural gas sources in 2001 to that in 2003?
Your answer should be compact. 0.92. What is the ratio of the Electricity production(% of total) of Oil sources in 2001 to that in 2003?
Your response must be concise. 0.68. What is the ratio of the Electricity production(% of total) of Coal sources in 2002 to that in 2003?
Offer a very short reply. 0.91. What is the ratio of the Electricity production(% of total) in Natural gas sources in 2002 to that in 2003?
Your answer should be very brief. 1.27. What is the ratio of the Electricity production(% of total) in Oil sources in 2002 to that in 2003?
Offer a terse response. 0.7. What is the difference between the highest and the second highest Electricity production(% of total) of Coal sources?
Your answer should be very brief. 1.8. What is the difference between the highest and the second highest Electricity production(% of total) of Natural gas sources?
Provide a short and direct response. 4.34. What is the difference between the highest and the second highest Electricity production(% of total) of Oil sources?
Offer a terse response. 0.78. What is the difference between the highest and the lowest Electricity production(% of total) in Coal sources?
Your response must be concise. 17.93. What is the difference between the highest and the lowest Electricity production(% of total) in Natural gas sources?
Offer a terse response. 10.6. What is the difference between the highest and the lowest Electricity production(% of total) of Oil sources?
Ensure brevity in your answer.  16.78. 